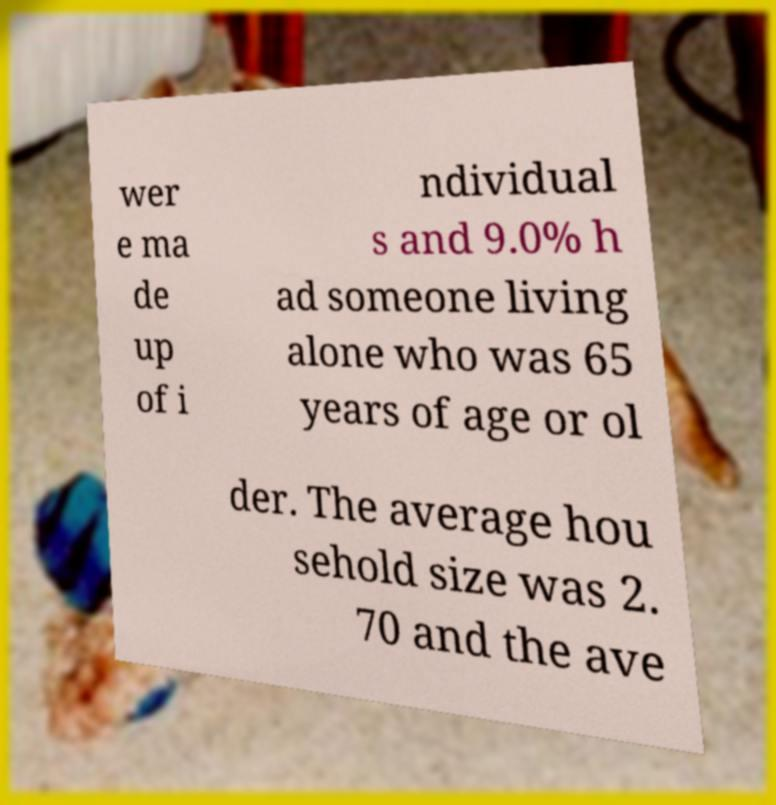Can you read and provide the text displayed in the image?This photo seems to have some interesting text. Can you extract and type it out for me? wer e ma de up of i ndividual s and 9.0% h ad someone living alone who was 65 years of age or ol der. The average hou sehold size was 2. 70 and the ave 